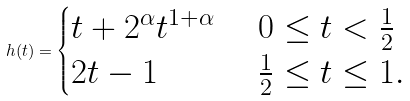<formula> <loc_0><loc_0><loc_500><loc_500>h ( t ) = \begin{cases} t + 2 ^ { \alpha } t ^ { 1 + \alpha } & \ 0 \leq t < \frac { 1 } { 2 } \\ 2 t - 1 & \ \frac { 1 } { 2 } \leq t \leq 1 . \end{cases}</formula> 